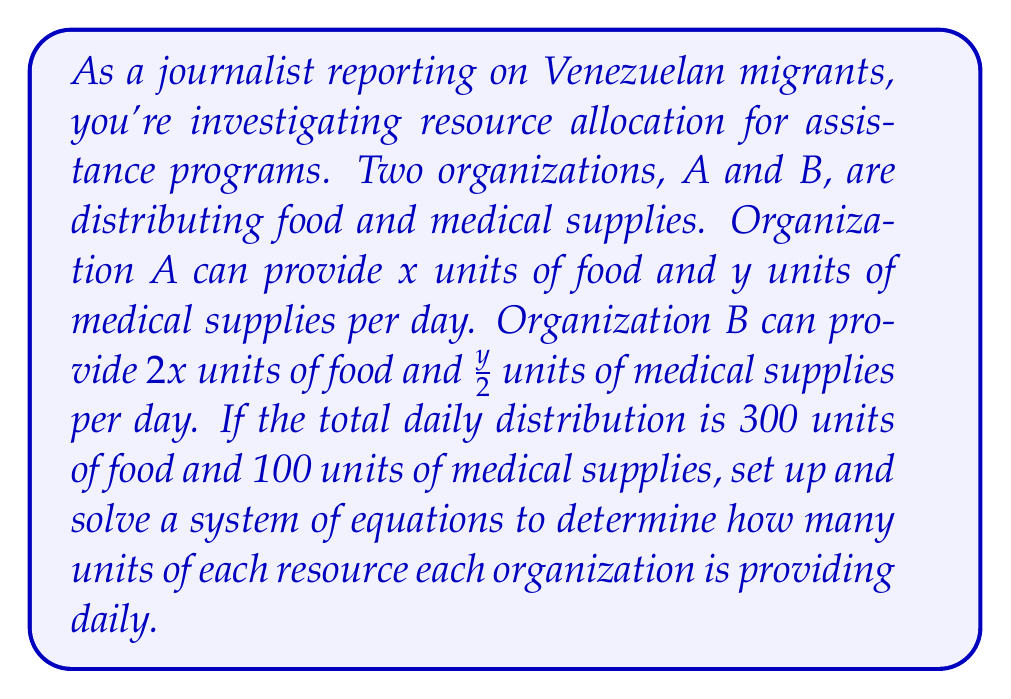Provide a solution to this math problem. Let's approach this step-by-step:

1) First, let's define our variables:
   $x$ = units of food provided by Organization A
   $y$ = units of medical supplies provided by Organization A

2) Now, let's set up our system of equations based on the given information:

   For food: $x + 2x = 300$ (Organization A + Organization B = Total)
   For medical supplies: $y + y/2 = 100$ (Organization A + Organization B = Total)

3) Let's simplify the first equation:
   $3x = 300$

4) Solve for $x$:
   $x = 100$

5) Now, let's solve the second equation:
   $y + y/2 = 100$
   $3y/2 = 100$
   $y = 200/3 \approx 66.67$

6) Now we know that Organization A provides:
   100 units of food
   66.67 units of medical supplies

7) We can calculate Organization B's contribution:
   Food: $2x = 2(100) = 200$ units
   Medical supplies: $y/2 = 66.67/2 \approx 33.33$ units

8) Let's verify our solution:
   Total food: $100 + 200 = 300$ units
   Total medical supplies: $66.67 + 33.33 = 100$ units
Answer: Organization A provides 100 units of food and approximately 66.67 units of medical supplies daily.
Organization B provides 200 units of food and approximately 33.33 units of medical supplies daily. 